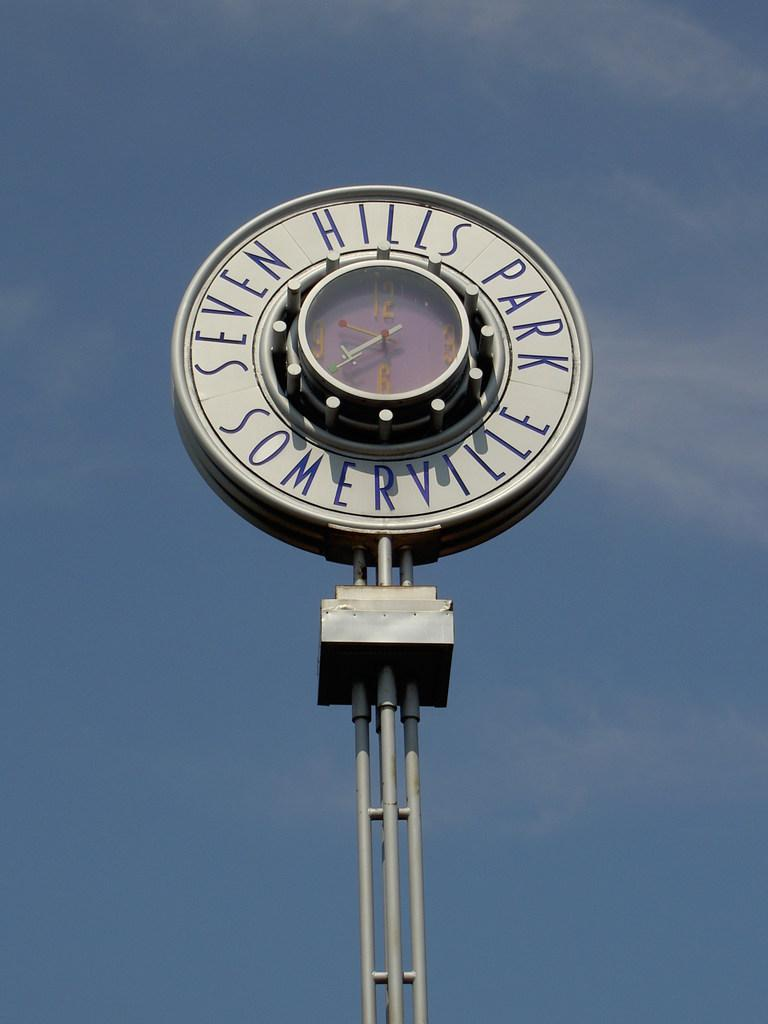<image>
Give a short and clear explanation of the subsequent image. A tall grey and blue sign which reads Seven Hills Park Somerville 